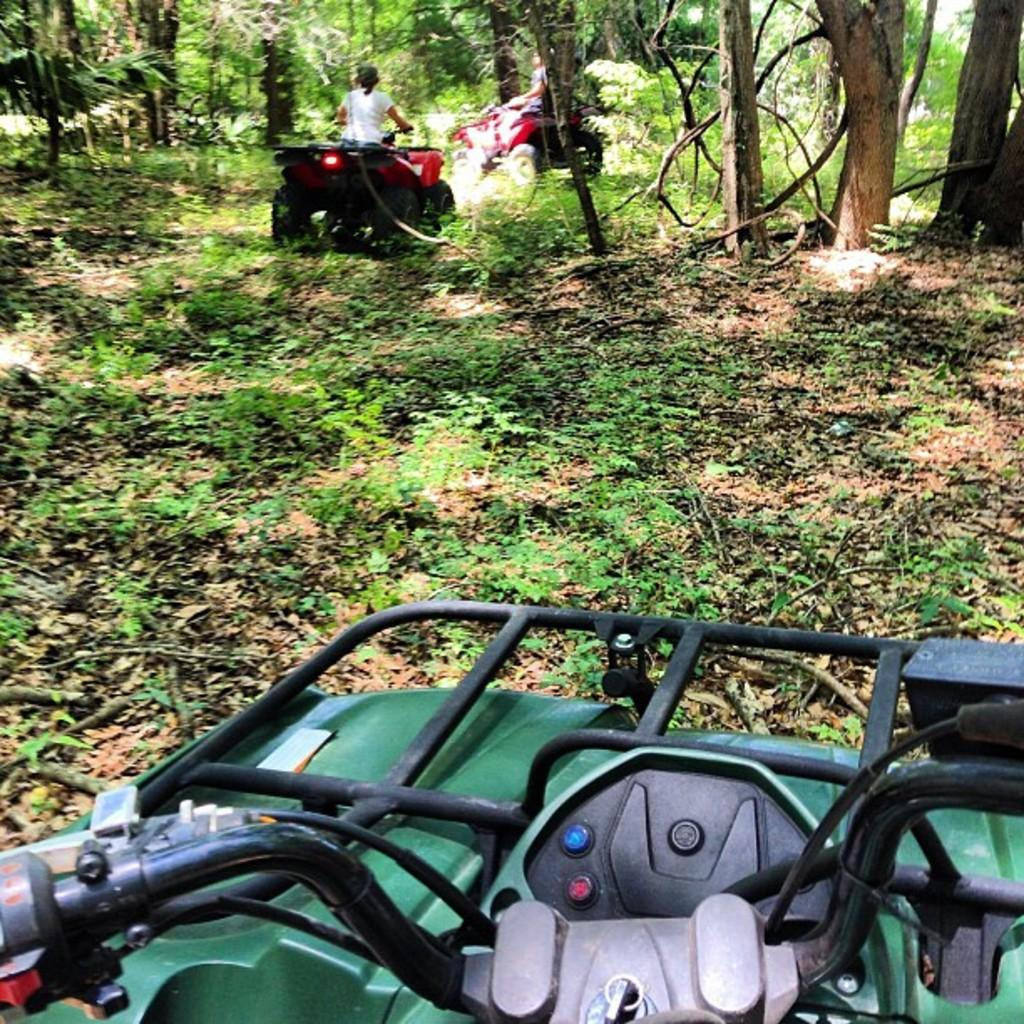What type of vegetation is present in the image? There is grass and trees in the image. What else can be seen in the image besides vegetation? There are vehicles and a person in the image. What type of drum is the mother holding in the image? There is no mother or drum present in the image. 